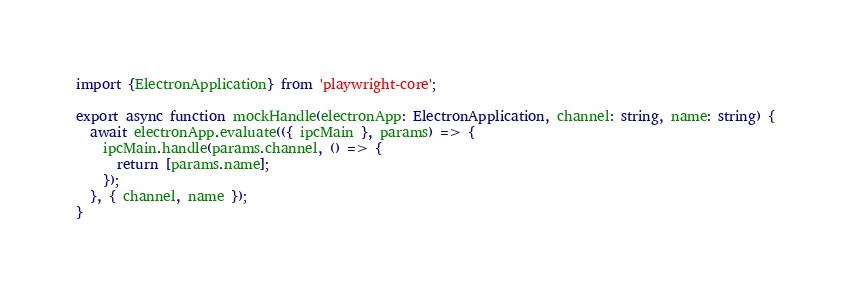<code> <loc_0><loc_0><loc_500><loc_500><_TypeScript_>import {ElectronApplication} from 'playwright-core';

export async function mockHandle(electronApp: ElectronApplication, channel: string, name: string) {
  await electronApp.evaluate(({ ipcMain }, params) => {
    ipcMain.handle(params.channel, () => {
      return [params.name];
    });
  }, { channel, name });
}
</code> 